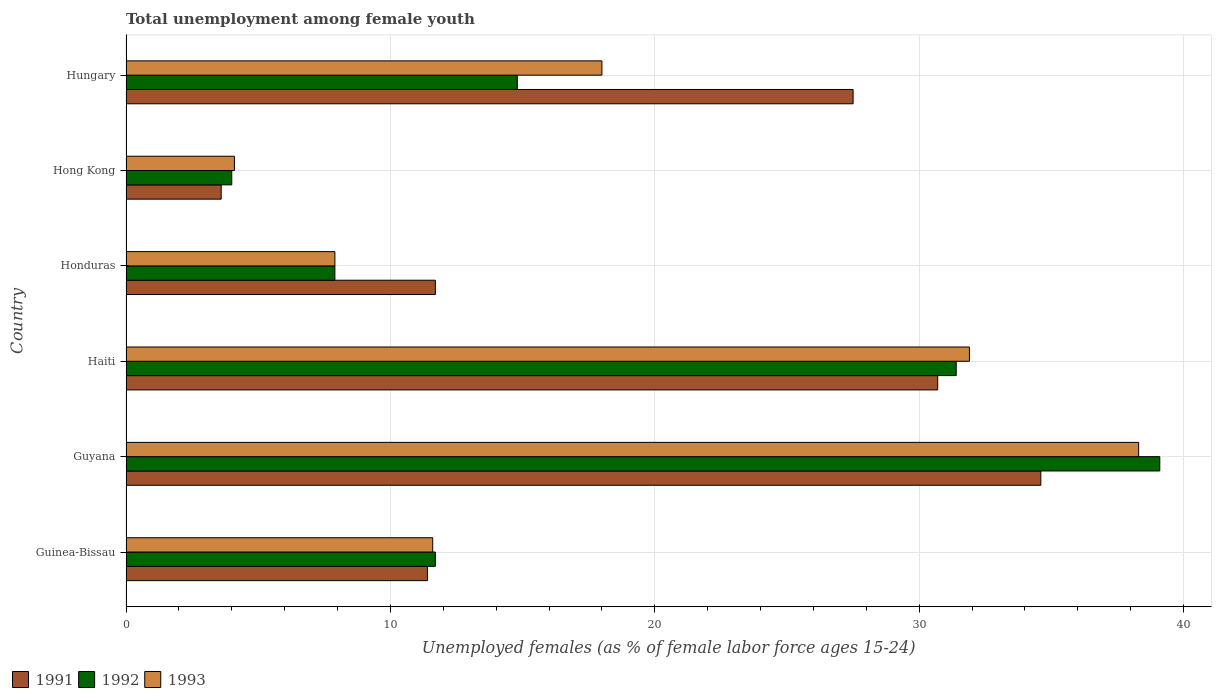How many different coloured bars are there?
Make the answer very short. 3. How many groups of bars are there?
Your response must be concise. 6. Are the number of bars per tick equal to the number of legend labels?
Your response must be concise. Yes. Are the number of bars on each tick of the Y-axis equal?
Make the answer very short. Yes. How many bars are there on the 5th tick from the top?
Your answer should be very brief. 3. What is the label of the 3rd group of bars from the top?
Provide a short and direct response. Honduras. Across all countries, what is the maximum percentage of unemployed females in in 1991?
Your answer should be compact. 34.6. Across all countries, what is the minimum percentage of unemployed females in in 1992?
Ensure brevity in your answer.  4. In which country was the percentage of unemployed females in in 1993 maximum?
Your answer should be very brief. Guyana. In which country was the percentage of unemployed females in in 1993 minimum?
Keep it short and to the point. Hong Kong. What is the total percentage of unemployed females in in 1992 in the graph?
Your response must be concise. 108.9. What is the difference between the percentage of unemployed females in in 1993 in Guinea-Bissau and that in Hong Kong?
Provide a short and direct response. 7.5. What is the difference between the percentage of unemployed females in in 1991 in Guyana and the percentage of unemployed females in in 1993 in Honduras?
Offer a very short reply. 26.7. What is the average percentage of unemployed females in in 1993 per country?
Keep it short and to the point. 18.63. What is the difference between the percentage of unemployed females in in 1991 and percentage of unemployed females in in 1993 in Hungary?
Provide a short and direct response. 9.5. In how many countries, is the percentage of unemployed females in in 1993 greater than 36 %?
Make the answer very short. 1. What is the ratio of the percentage of unemployed females in in 1993 in Haiti to that in Hong Kong?
Your answer should be very brief. 7.78. Is the percentage of unemployed females in in 1991 in Honduras less than that in Hungary?
Your answer should be very brief. Yes. What is the difference between the highest and the second highest percentage of unemployed females in in 1991?
Ensure brevity in your answer.  3.9. What is the difference between the highest and the lowest percentage of unemployed females in in 1992?
Your response must be concise. 35.1. Is the sum of the percentage of unemployed females in in 1992 in Haiti and Hungary greater than the maximum percentage of unemployed females in in 1991 across all countries?
Offer a very short reply. Yes. What does the 3rd bar from the top in Guinea-Bissau represents?
Your response must be concise. 1991. How many bars are there?
Keep it short and to the point. 18. Are the values on the major ticks of X-axis written in scientific E-notation?
Provide a short and direct response. No. Does the graph contain any zero values?
Your answer should be very brief. No. Does the graph contain grids?
Make the answer very short. Yes. Where does the legend appear in the graph?
Offer a very short reply. Bottom left. How many legend labels are there?
Provide a short and direct response. 3. What is the title of the graph?
Offer a very short reply. Total unemployment among female youth. What is the label or title of the X-axis?
Offer a terse response. Unemployed females (as % of female labor force ages 15-24). What is the label or title of the Y-axis?
Provide a succinct answer. Country. What is the Unemployed females (as % of female labor force ages 15-24) in 1991 in Guinea-Bissau?
Ensure brevity in your answer.  11.4. What is the Unemployed females (as % of female labor force ages 15-24) in 1992 in Guinea-Bissau?
Offer a terse response. 11.7. What is the Unemployed females (as % of female labor force ages 15-24) in 1993 in Guinea-Bissau?
Give a very brief answer. 11.6. What is the Unemployed females (as % of female labor force ages 15-24) of 1991 in Guyana?
Make the answer very short. 34.6. What is the Unemployed females (as % of female labor force ages 15-24) of 1992 in Guyana?
Offer a very short reply. 39.1. What is the Unemployed females (as % of female labor force ages 15-24) of 1993 in Guyana?
Your answer should be very brief. 38.3. What is the Unemployed females (as % of female labor force ages 15-24) in 1991 in Haiti?
Offer a terse response. 30.7. What is the Unemployed females (as % of female labor force ages 15-24) of 1992 in Haiti?
Your answer should be compact. 31.4. What is the Unemployed females (as % of female labor force ages 15-24) of 1993 in Haiti?
Your response must be concise. 31.9. What is the Unemployed females (as % of female labor force ages 15-24) in 1991 in Honduras?
Your answer should be very brief. 11.7. What is the Unemployed females (as % of female labor force ages 15-24) in 1992 in Honduras?
Offer a terse response. 7.9. What is the Unemployed females (as % of female labor force ages 15-24) of 1993 in Honduras?
Offer a very short reply. 7.9. What is the Unemployed females (as % of female labor force ages 15-24) in 1991 in Hong Kong?
Your answer should be very brief. 3.6. What is the Unemployed females (as % of female labor force ages 15-24) of 1993 in Hong Kong?
Ensure brevity in your answer.  4.1. What is the Unemployed females (as % of female labor force ages 15-24) in 1992 in Hungary?
Offer a very short reply. 14.8. What is the Unemployed females (as % of female labor force ages 15-24) in 1993 in Hungary?
Your answer should be very brief. 18. Across all countries, what is the maximum Unemployed females (as % of female labor force ages 15-24) in 1991?
Offer a very short reply. 34.6. Across all countries, what is the maximum Unemployed females (as % of female labor force ages 15-24) in 1992?
Offer a very short reply. 39.1. Across all countries, what is the maximum Unemployed females (as % of female labor force ages 15-24) of 1993?
Make the answer very short. 38.3. Across all countries, what is the minimum Unemployed females (as % of female labor force ages 15-24) of 1991?
Provide a succinct answer. 3.6. Across all countries, what is the minimum Unemployed females (as % of female labor force ages 15-24) of 1993?
Provide a short and direct response. 4.1. What is the total Unemployed females (as % of female labor force ages 15-24) of 1991 in the graph?
Keep it short and to the point. 119.5. What is the total Unemployed females (as % of female labor force ages 15-24) in 1992 in the graph?
Offer a terse response. 108.9. What is the total Unemployed females (as % of female labor force ages 15-24) of 1993 in the graph?
Give a very brief answer. 111.8. What is the difference between the Unemployed females (as % of female labor force ages 15-24) of 1991 in Guinea-Bissau and that in Guyana?
Ensure brevity in your answer.  -23.2. What is the difference between the Unemployed females (as % of female labor force ages 15-24) in 1992 in Guinea-Bissau and that in Guyana?
Offer a very short reply. -27.4. What is the difference between the Unemployed females (as % of female labor force ages 15-24) in 1993 in Guinea-Bissau and that in Guyana?
Offer a terse response. -26.7. What is the difference between the Unemployed females (as % of female labor force ages 15-24) in 1991 in Guinea-Bissau and that in Haiti?
Provide a succinct answer. -19.3. What is the difference between the Unemployed females (as % of female labor force ages 15-24) in 1992 in Guinea-Bissau and that in Haiti?
Keep it short and to the point. -19.7. What is the difference between the Unemployed females (as % of female labor force ages 15-24) of 1993 in Guinea-Bissau and that in Haiti?
Provide a short and direct response. -20.3. What is the difference between the Unemployed females (as % of female labor force ages 15-24) of 1991 in Guinea-Bissau and that in Honduras?
Your answer should be compact. -0.3. What is the difference between the Unemployed females (as % of female labor force ages 15-24) in 1993 in Guinea-Bissau and that in Honduras?
Your response must be concise. 3.7. What is the difference between the Unemployed females (as % of female labor force ages 15-24) of 1993 in Guinea-Bissau and that in Hong Kong?
Give a very brief answer. 7.5. What is the difference between the Unemployed females (as % of female labor force ages 15-24) in 1991 in Guinea-Bissau and that in Hungary?
Offer a terse response. -16.1. What is the difference between the Unemployed females (as % of female labor force ages 15-24) in 1992 in Guinea-Bissau and that in Hungary?
Ensure brevity in your answer.  -3.1. What is the difference between the Unemployed females (as % of female labor force ages 15-24) in 1991 in Guyana and that in Haiti?
Your response must be concise. 3.9. What is the difference between the Unemployed females (as % of female labor force ages 15-24) of 1992 in Guyana and that in Haiti?
Your answer should be compact. 7.7. What is the difference between the Unemployed females (as % of female labor force ages 15-24) in 1993 in Guyana and that in Haiti?
Provide a short and direct response. 6.4. What is the difference between the Unemployed females (as % of female labor force ages 15-24) of 1991 in Guyana and that in Honduras?
Keep it short and to the point. 22.9. What is the difference between the Unemployed females (as % of female labor force ages 15-24) of 1992 in Guyana and that in Honduras?
Your answer should be compact. 31.2. What is the difference between the Unemployed females (as % of female labor force ages 15-24) of 1993 in Guyana and that in Honduras?
Your response must be concise. 30.4. What is the difference between the Unemployed females (as % of female labor force ages 15-24) of 1991 in Guyana and that in Hong Kong?
Ensure brevity in your answer.  31. What is the difference between the Unemployed females (as % of female labor force ages 15-24) of 1992 in Guyana and that in Hong Kong?
Ensure brevity in your answer.  35.1. What is the difference between the Unemployed females (as % of female labor force ages 15-24) of 1993 in Guyana and that in Hong Kong?
Provide a short and direct response. 34.2. What is the difference between the Unemployed females (as % of female labor force ages 15-24) of 1992 in Guyana and that in Hungary?
Your response must be concise. 24.3. What is the difference between the Unemployed females (as % of female labor force ages 15-24) in 1993 in Guyana and that in Hungary?
Make the answer very short. 20.3. What is the difference between the Unemployed females (as % of female labor force ages 15-24) of 1991 in Haiti and that in Honduras?
Keep it short and to the point. 19. What is the difference between the Unemployed females (as % of female labor force ages 15-24) of 1993 in Haiti and that in Honduras?
Keep it short and to the point. 24. What is the difference between the Unemployed females (as % of female labor force ages 15-24) in 1991 in Haiti and that in Hong Kong?
Provide a succinct answer. 27.1. What is the difference between the Unemployed females (as % of female labor force ages 15-24) in 1992 in Haiti and that in Hong Kong?
Your answer should be very brief. 27.4. What is the difference between the Unemployed females (as % of female labor force ages 15-24) of 1993 in Haiti and that in Hong Kong?
Ensure brevity in your answer.  27.8. What is the difference between the Unemployed females (as % of female labor force ages 15-24) in 1993 in Haiti and that in Hungary?
Make the answer very short. 13.9. What is the difference between the Unemployed females (as % of female labor force ages 15-24) of 1993 in Honduras and that in Hong Kong?
Provide a succinct answer. 3.8. What is the difference between the Unemployed females (as % of female labor force ages 15-24) of 1991 in Honduras and that in Hungary?
Your answer should be very brief. -15.8. What is the difference between the Unemployed females (as % of female labor force ages 15-24) in 1992 in Honduras and that in Hungary?
Your answer should be compact. -6.9. What is the difference between the Unemployed females (as % of female labor force ages 15-24) of 1991 in Hong Kong and that in Hungary?
Offer a terse response. -23.9. What is the difference between the Unemployed females (as % of female labor force ages 15-24) of 1992 in Hong Kong and that in Hungary?
Provide a short and direct response. -10.8. What is the difference between the Unemployed females (as % of female labor force ages 15-24) of 1991 in Guinea-Bissau and the Unemployed females (as % of female labor force ages 15-24) of 1992 in Guyana?
Offer a very short reply. -27.7. What is the difference between the Unemployed females (as % of female labor force ages 15-24) in 1991 in Guinea-Bissau and the Unemployed females (as % of female labor force ages 15-24) in 1993 in Guyana?
Give a very brief answer. -26.9. What is the difference between the Unemployed females (as % of female labor force ages 15-24) of 1992 in Guinea-Bissau and the Unemployed females (as % of female labor force ages 15-24) of 1993 in Guyana?
Your response must be concise. -26.6. What is the difference between the Unemployed females (as % of female labor force ages 15-24) of 1991 in Guinea-Bissau and the Unemployed females (as % of female labor force ages 15-24) of 1992 in Haiti?
Give a very brief answer. -20. What is the difference between the Unemployed females (as % of female labor force ages 15-24) of 1991 in Guinea-Bissau and the Unemployed females (as % of female labor force ages 15-24) of 1993 in Haiti?
Ensure brevity in your answer.  -20.5. What is the difference between the Unemployed females (as % of female labor force ages 15-24) in 1992 in Guinea-Bissau and the Unemployed females (as % of female labor force ages 15-24) in 1993 in Haiti?
Offer a very short reply. -20.2. What is the difference between the Unemployed females (as % of female labor force ages 15-24) of 1991 in Guinea-Bissau and the Unemployed females (as % of female labor force ages 15-24) of 1993 in Honduras?
Give a very brief answer. 3.5. What is the difference between the Unemployed females (as % of female labor force ages 15-24) in 1992 in Guinea-Bissau and the Unemployed females (as % of female labor force ages 15-24) in 1993 in Honduras?
Provide a short and direct response. 3.8. What is the difference between the Unemployed females (as % of female labor force ages 15-24) of 1991 in Guinea-Bissau and the Unemployed females (as % of female labor force ages 15-24) of 1992 in Hong Kong?
Keep it short and to the point. 7.4. What is the difference between the Unemployed females (as % of female labor force ages 15-24) in 1991 in Guinea-Bissau and the Unemployed females (as % of female labor force ages 15-24) in 1993 in Hong Kong?
Your response must be concise. 7.3. What is the difference between the Unemployed females (as % of female labor force ages 15-24) in 1992 in Guinea-Bissau and the Unemployed females (as % of female labor force ages 15-24) in 1993 in Hong Kong?
Provide a succinct answer. 7.6. What is the difference between the Unemployed females (as % of female labor force ages 15-24) of 1991 in Guyana and the Unemployed females (as % of female labor force ages 15-24) of 1992 in Haiti?
Offer a very short reply. 3.2. What is the difference between the Unemployed females (as % of female labor force ages 15-24) of 1991 in Guyana and the Unemployed females (as % of female labor force ages 15-24) of 1992 in Honduras?
Offer a terse response. 26.7. What is the difference between the Unemployed females (as % of female labor force ages 15-24) of 1991 in Guyana and the Unemployed females (as % of female labor force ages 15-24) of 1993 in Honduras?
Ensure brevity in your answer.  26.7. What is the difference between the Unemployed females (as % of female labor force ages 15-24) in 1992 in Guyana and the Unemployed females (as % of female labor force ages 15-24) in 1993 in Honduras?
Offer a very short reply. 31.2. What is the difference between the Unemployed females (as % of female labor force ages 15-24) of 1991 in Guyana and the Unemployed females (as % of female labor force ages 15-24) of 1992 in Hong Kong?
Your answer should be very brief. 30.6. What is the difference between the Unemployed females (as % of female labor force ages 15-24) of 1991 in Guyana and the Unemployed females (as % of female labor force ages 15-24) of 1993 in Hong Kong?
Make the answer very short. 30.5. What is the difference between the Unemployed females (as % of female labor force ages 15-24) of 1992 in Guyana and the Unemployed females (as % of female labor force ages 15-24) of 1993 in Hong Kong?
Your response must be concise. 35. What is the difference between the Unemployed females (as % of female labor force ages 15-24) of 1991 in Guyana and the Unemployed females (as % of female labor force ages 15-24) of 1992 in Hungary?
Offer a terse response. 19.8. What is the difference between the Unemployed females (as % of female labor force ages 15-24) in 1991 in Guyana and the Unemployed females (as % of female labor force ages 15-24) in 1993 in Hungary?
Offer a very short reply. 16.6. What is the difference between the Unemployed females (as % of female labor force ages 15-24) of 1992 in Guyana and the Unemployed females (as % of female labor force ages 15-24) of 1993 in Hungary?
Your answer should be very brief. 21.1. What is the difference between the Unemployed females (as % of female labor force ages 15-24) in 1991 in Haiti and the Unemployed females (as % of female labor force ages 15-24) in 1992 in Honduras?
Make the answer very short. 22.8. What is the difference between the Unemployed females (as % of female labor force ages 15-24) of 1991 in Haiti and the Unemployed females (as % of female labor force ages 15-24) of 1993 in Honduras?
Your response must be concise. 22.8. What is the difference between the Unemployed females (as % of female labor force ages 15-24) of 1992 in Haiti and the Unemployed females (as % of female labor force ages 15-24) of 1993 in Honduras?
Keep it short and to the point. 23.5. What is the difference between the Unemployed females (as % of female labor force ages 15-24) in 1991 in Haiti and the Unemployed females (as % of female labor force ages 15-24) in 1992 in Hong Kong?
Keep it short and to the point. 26.7. What is the difference between the Unemployed females (as % of female labor force ages 15-24) of 1991 in Haiti and the Unemployed females (as % of female labor force ages 15-24) of 1993 in Hong Kong?
Your answer should be very brief. 26.6. What is the difference between the Unemployed females (as % of female labor force ages 15-24) in 1992 in Haiti and the Unemployed females (as % of female labor force ages 15-24) in 1993 in Hong Kong?
Make the answer very short. 27.3. What is the difference between the Unemployed females (as % of female labor force ages 15-24) of 1991 in Haiti and the Unemployed females (as % of female labor force ages 15-24) of 1992 in Hungary?
Ensure brevity in your answer.  15.9. What is the difference between the Unemployed females (as % of female labor force ages 15-24) in 1991 in Haiti and the Unemployed females (as % of female labor force ages 15-24) in 1993 in Hungary?
Offer a terse response. 12.7. What is the difference between the Unemployed females (as % of female labor force ages 15-24) in 1992 in Haiti and the Unemployed females (as % of female labor force ages 15-24) in 1993 in Hungary?
Offer a very short reply. 13.4. What is the difference between the Unemployed females (as % of female labor force ages 15-24) of 1991 in Honduras and the Unemployed females (as % of female labor force ages 15-24) of 1992 in Hong Kong?
Keep it short and to the point. 7.7. What is the difference between the Unemployed females (as % of female labor force ages 15-24) in 1991 in Honduras and the Unemployed females (as % of female labor force ages 15-24) in 1993 in Hong Kong?
Make the answer very short. 7.6. What is the difference between the Unemployed females (as % of female labor force ages 15-24) of 1991 in Honduras and the Unemployed females (as % of female labor force ages 15-24) of 1992 in Hungary?
Provide a succinct answer. -3.1. What is the difference between the Unemployed females (as % of female labor force ages 15-24) in 1991 in Honduras and the Unemployed females (as % of female labor force ages 15-24) in 1993 in Hungary?
Offer a terse response. -6.3. What is the difference between the Unemployed females (as % of female labor force ages 15-24) of 1991 in Hong Kong and the Unemployed females (as % of female labor force ages 15-24) of 1993 in Hungary?
Make the answer very short. -14.4. What is the average Unemployed females (as % of female labor force ages 15-24) in 1991 per country?
Your response must be concise. 19.92. What is the average Unemployed females (as % of female labor force ages 15-24) of 1992 per country?
Keep it short and to the point. 18.15. What is the average Unemployed females (as % of female labor force ages 15-24) in 1993 per country?
Your answer should be very brief. 18.63. What is the difference between the Unemployed females (as % of female labor force ages 15-24) in 1991 and Unemployed females (as % of female labor force ages 15-24) in 1993 in Guinea-Bissau?
Your answer should be compact. -0.2. What is the difference between the Unemployed females (as % of female labor force ages 15-24) of 1991 and Unemployed females (as % of female labor force ages 15-24) of 1992 in Guyana?
Keep it short and to the point. -4.5. What is the difference between the Unemployed females (as % of female labor force ages 15-24) in 1992 and Unemployed females (as % of female labor force ages 15-24) in 1993 in Guyana?
Provide a short and direct response. 0.8. What is the difference between the Unemployed females (as % of female labor force ages 15-24) of 1991 and Unemployed females (as % of female labor force ages 15-24) of 1993 in Honduras?
Ensure brevity in your answer.  3.8. What is the difference between the Unemployed females (as % of female labor force ages 15-24) in 1991 and Unemployed females (as % of female labor force ages 15-24) in 1993 in Hong Kong?
Offer a terse response. -0.5. What is the difference between the Unemployed females (as % of female labor force ages 15-24) in 1991 and Unemployed females (as % of female labor force ages 15-24) in 1992 in Hungary?
Ensure brevity in your answer.  12.7. What is the difference between the Unemployed females (as % of female labor force ages 15-24) of 1991 and Unemployed females (as % of female labor force ages 15-24) of 1993 in Hungary?
Offer a very short reply. 9.5. What is the ratio of the Unemployed females (as % of female labor force ages 15-24) of 1991 in Guinea-Bissau to that in Guyana?
Provide a succinct answer. 0.33. What is the ratio of the Unemployed females (as % of female labor force ages 15-24) of 1992 in Guinea-Bissau to that in Guyana?
Offer a terse response. 0.3. What is the ratio of the Unemployed females (as % of female labor force ages 15-24) of 1993 in Guinea-Bissau to that in Guyana?
Offer a terse response. 0.3. What is the ratio of the Unemployed females (as % of female labor force ages 15-24) of 1991 in Guinea-Bissau to that in Haiti?
Keep it short and to the point. 0.37. What is the ratio of the Unemployed females (as % of female labor force ages 15-24) of 1992 in Guinea-Bissau to that in Haiti?
Your response must be concise. 0.37. What is the ratio of the Unemployed females (as % of female labor force ages 15-24) of 1993 in Guinea-Bissau to that in Haiti?
Offer a very short reply. 0.36. What is the ratio of the Unemployed females (as % of female labor force ages 15-24) of 1991 in Guinea-Bissau to that in Honduras?
Give a very brief answer. 0.97. What is the ratio of the Unemployed females (as % of female labor force ages 15-24) of 1992 in Guinea-Bissau to that in Honduras?
Provide a succinct answer. 1.48. What is the ratio of the Unemployed females (as % of female labor force ages 15-24) of 1993 in Guinea-Bissau to that in Honduras?
Your answer should be very brief. 1.47. What is the ratio of the Unemployed females (as % of female labor force ages 15-24) in 1991 in Guinea-Bissau to that in Hong Kong?
Offer a terse response. 3.17. What is the ratio of the Unemployed females (as % of female labor force ages 15-24) of 1992 in Guinea-Bissau to that in Hong Kong?
Ensure brevity in your answer.  2.92. What is the ratio of the Unemployed females (as % of female labor force ages 15-24) in 1993 in Guinea-Bissau to that in Hong Kong?
Offer a terse response. 2.83. What is the ratio of the Unemployed females (as % of female labor force ages 15-24) of 1991 in Guinea-Bissau to that in Hungary?
Your response must be concise. 0.41. What is the ratio of the Unemployed females (as % of female labor force ages 15-24) of 1992 in Guinea-Bissau to that in Hungary?
Ensure brevity in your answer.  0.79. What is the ratio of the Unemployed females (as % of female labor force ages 15-24) in 1993 in Guinea-Bissau to that in Hungary?
Provide a succinct answer. 0.64. What is the ratio of the Unemployed females (as % of female labor force ages 15-24) of 1991 in Guyana to that in Haiti?
Ensure brevity in your answer.  1.13. What is the ratio of the Unemployed females (as % of female labor force ages 15-24) in 1992 in Guyana to that in Haiti?
Provide a short and direct response. 1.25. What is the ratio of the Unemployed females (as % of female labor force ages 15-24) of 1993 in Guyana to that in Haiti?
Provide a succinct answer. 1.2. What is the ratio of the Unemployed females (as % of female labor force ages 15-24) in 1991 in Guyana to that in Honduras?
Offer a terse response. 2.96. What is the ratio of the Unemployed females (as % of female labor force ages 15-24) of 1992 in Guyana to that in Honduras?
Offer a terse response. 4.95. What is the ratio of the Unemployed females (as % of female labor force ages 15-24) of 1993 in Guyana to that in Honduras?
Your response must be concise. 4.85. What is the ratio of the Unemployed females (as % of female labor force ages 15-24) of 1991 in Guyana to that in Hong Kong?
Offer a very short reply. 9.61. What is the ratio of the Unemployed females (as % of female labor force ages 15-24) in 1992 in Guyana to that in Hong Kong?
Offer a very short reply. 9.78. What is the ratio of the Unemployed females (as % of female labor force ages 15-24) of 1993 in Guyana to that in Hong Kong?
Provide a succinct answer. 9.34. What is the ratio of the Unemployed females (as % of female labor force ages 15-24) in 1991 in Guyana to that in Hungary?
Ensure brevity in your answer.  1.26. What is the ratio of the Unemployed females (as % of female labor force ages 15-24) in 1992 in Guyana to that in Hungary?
Provide a short and direct response. 2.64. What is the ratio of the Unemployed females (as % of female labor force ages 15-24) of 1993 in Guyana to that in Hungary?
Offer a terse response. 2.13. What is the ratio of the Unemployed females (as % of female labor force ages 15-24) in 1991 in Haiti to that in Honduras?
Give a very brief answer. 2.62. What is the ratio of the Unemployed females (as % of female labor force ages 15-24) in 1992 in Haiti to that in Honduras?
Offer a very short reply. 3.97. What is the ratio of the Unemployed females (as % of female labor force ages 15-24) of 1993 in Haiti to that in Honduras?
Your response must be concise. 4.04. What is the ratio of the Unemployed females (as % of female labor force ages 15-24) in 1991 in Haiti to that in Hong Kong?
Give a very brief answer. 8.53. What is the ratio of the Unemployed females (as % of female labor force ages 15-24) in 1992 in Haiti to that in Hong Kong?
Ensure brevity in your answer.  7.85. What is the ratio of the Unemployed females (as % of female labor force ages 15-24) of 1993 in Haiti to that in Hong Kong?
Give a very brief answer. 7.78. What is the ratio of the Unemployed females (as % of female labor force ages 15-24) in 1991 in Haiti to that in Hungary?
Ensure brevity in your answer.  1.12. What is the ratio of the Unemployed females (as % of female labor force ages 15-24) of 1992 in Haiti to that in Hungary?
Make the answer very short. 2.12. What is the ratio of the Unemployed females (as % of female labor force ages 15-24) of 1993 in Haiti to that in Hungary?
Offer a very short reply. 1.77. What is the ratio of the Unemployed females (as % of female labor force ages 15-24) of 1991 in Honduras to that in Hong Kong?
Keep it short and to the point. 3.25. What is the ratio of the Unemployed females (as % of female labor force ages 15-24) of 1992 in Honduras to that in Hong Kong?
Offer a terse response. 1.98. What is the ratio of the Unemployed females (as % of female labor force ages 15-24) in 1993 in Honduras to that in Hong Kong?
Your answer should be compact. 1.93. What is the ratio of the Unemployed females (as % of female labor force ages 15-24) in 1991 in Honduras to that in Hungary?
Your answer should be compact. 0.43. What is the ratio of the Unemployed females (as % of female labor force ages 15-24) in 1992 in Honduras to that in Hungary?
Provide a succinct answer. 0.53. What is the ratio of the Unemployed females (as % of female labor force ages 15-24) in 1993 in Honduras to that in Hungary?
Make the answer very short. 0.44. What is the ratio of the Unemployed females (as % of female labor force ages 15-24) of 1991 in Hong Kong to that in Hungary?
Your answer should be compact. 0.13. What is the ratio of the Unemployed females (as % of female labor force ages 15-24) of 1992 in Hong Kong to that in Hungary?
Offer a very short reply. 0.27. What is the ratio of the Unemployed females (as % of female labor force ages 15-24) of 1993 in Hong Kong to that in Hungary?
Provide a short and direct response. 0.23. What is the difference between the highest and the second highest Unemployed females (as % of female labor force ages 15-24) in 1991?
Provide a succinct answer. 3.9. What is the difference between the highest and the lowest Unemployed females (as % of female labor force ages 15-24) in 1991?
Your answer should be very brief. 31. What is the difference between the highest and the lowest Unemployed females (as % of female labor force ages 15-24) in 1992?
Offer a terse response. 35.1. What is the difference between the highest and the lowest Unemployed females (as % of female labor force ages 15-24) of 1993?
Offer a terse response. 34.2. 